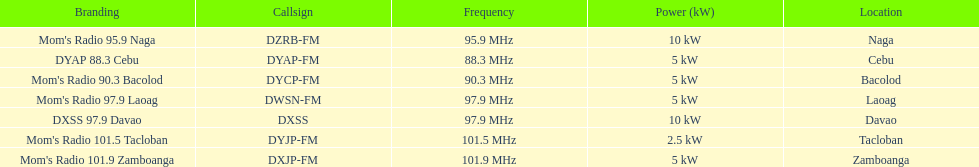What is the radio with the most mhz? Mom's Radio 101.9 Zamboanga. 